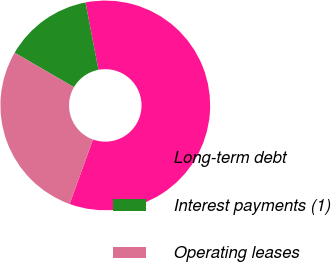Convert chart. <chart><loc_0><loc_0><loc_500><loc_500><pie_chart><fcel>Long-term debt<fcel>Interest payments (1)<fcel>Operating leases<nl><fcel>58.54%<fcel>13.6%<fcel>27.85%<nl></chart> 